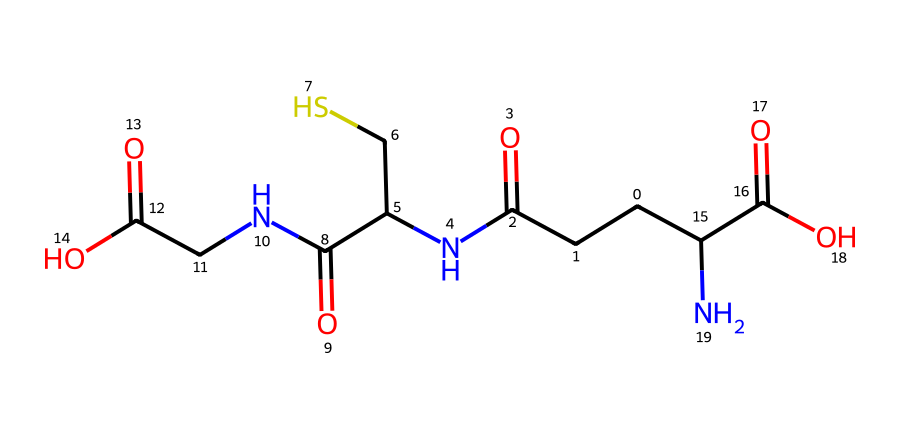What is the molecular formula of glutathione? The SMILES representation indicates the presence of carbon, hydrogen, oxygen, nitrogen, and sulfur atoms. Counting the distinct atoms, the molecular formula can be derived by noting the number of each type of atom present from the SMILES.
Answer: C10H17N3O6S How many nitrogen atoms are present in glutathione? By reviewing the SMILES structure, one can identify the nitrogen atoms represented by the 'N' symbols in the structure. There are three distinct nitrogen atoms.
Answer: 3 What type of bond is primarily present between carbon and nitrogen in glutathione? In the SMILES representation, the linkages involving carbon and nitrogen primarily suggest the presence of amide bonds, which are characteristic of proteins. Thus, they likely feature C-N single bonds.
Answer: amide How does the presence of sulfur affect the antioxidant properties of glutathione? Sulfur is crucial for the formation of disulfide bonds between cysteine residues, impacting the redox state in cellular reactions. This is crucial for glutathione's role in detoxifying reactive oxygen species and thus enhancing its antioxidant properties.
Answer: enhances What functional groups can be identified in glutathione? By analyzing the distinct parts of the SMILES, one can find various functional groups such as carboxylic acids and amides. Each segment of the chemical code reflects these groups contributing to its biochemical functionality.
Answer: carboxylic acids and amides What is the role of glutathione in cellular defense? Glutathione acts as a key antioxidant, protecting cells from oxidative stress by reducing free radicals and reactive oxygen species, thus, maintaining cellular health and function.
Answer: antioxidant 